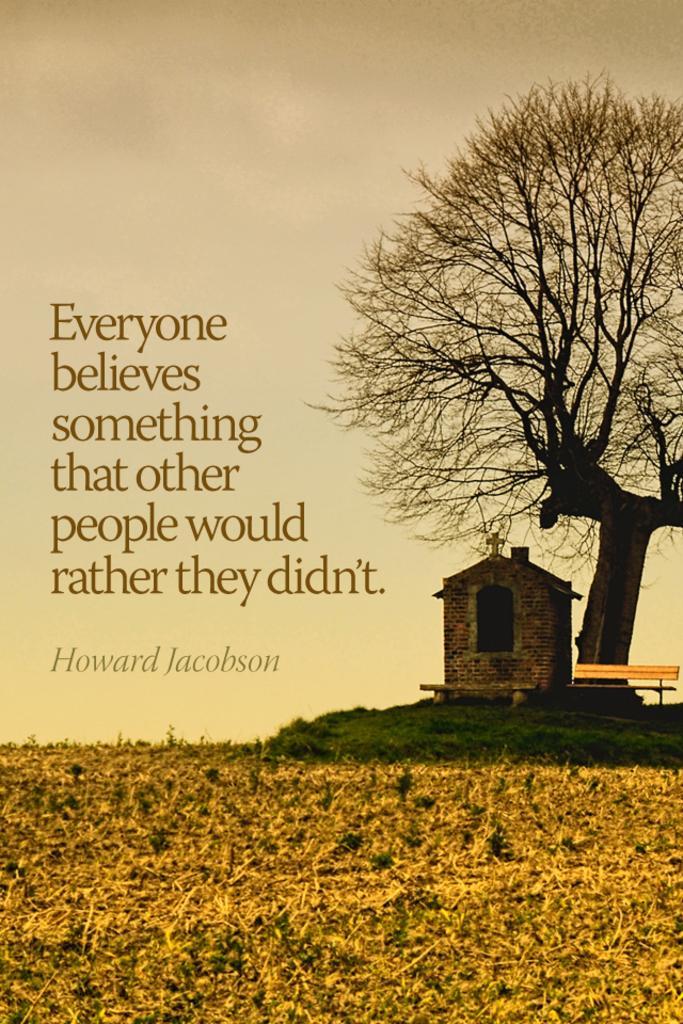In one or two sentences, can you explain what this image depicts? This looks like a poster with a quotation on it. Here is the tree with branches. This is the bench. I can see a small house with a holy cross symbol. This is the grass. This looks like a dried grass, which is yellow in color. 